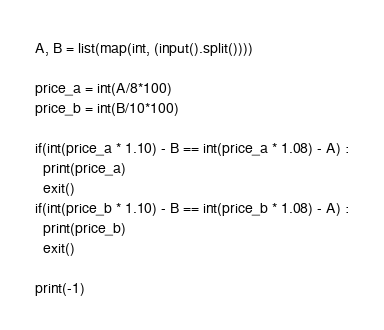Convert code to text. <code><loc_0><loc_0><loc_500><loc_500><_Python_>A, B = list(map(int, (input().split())))

price_a = int(A/8*100)
price_b = int(B/10*100)

if(int(price_a * 1.10) - B == int(price_a * 1.08) - A) :
  print(price_a)
  exit()
if(int(price_b * 1.10) - B == int(price_b * 1.08) - A) :
  print(price_b)
  exit()
  
print(-1)</code> 